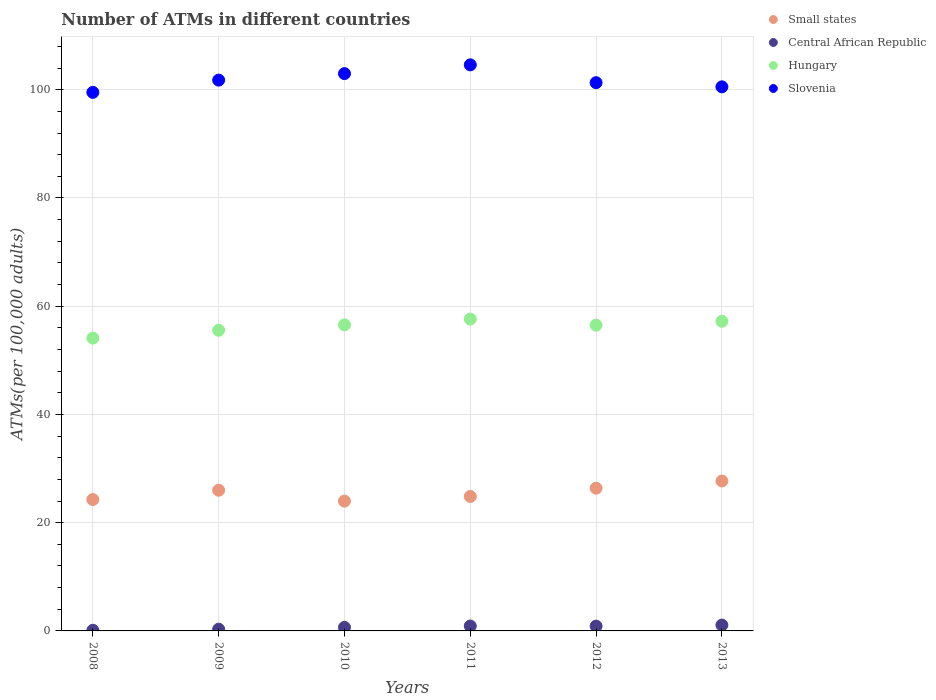What is the number of ATMs in Central African Republic in 2011?
Your answer should be very brief. 0.91. Across all years, what is the maximum number of ATMs in Hungary?
Make the answer very short. 57.63. Across all years, what is the minimum number of ATMs in Hungary?
Make the answer very short. 54.1. In which year was the number of ATMs in Small states minimum?
Your answer should be compact. 2010. What is the total number of ATMs in Slovenia in the graph?
Your response must be concise. 610.71. What is the difference between the number of ATMs in Hungary in 2009 and that in 2011?
Make the answer very short. -2.07. What is the difference between the number of ATMs in Small states in 2008 and the number of ATMs in Central African Republic in 2009?
Your answer should be very brief. 23.96. What is the average number of ATMs in Hungary per year?
Offer a terse response. 56.26. In the year 2010, what is the difference between the number of ATMs in Central African Republic and number of ATMs in Small states?
Your answer should be compact. -23.33. In how many years, is the number of ATMs in Small states greater than 76?
Provide a short and direct response. 0. What is the ratio of the number of ATMs in Slovenia in 2008 to that in 2011?
Your answer should be very brief. 0.95. Is the difference between the number of ATMs in Central African Republic in 2009 and 2010 greater than the difference between the number of ATMs in Small states in 2009 and 2010?
Give a very brief answer. No. What is the difference between the highest and the second highest number of ATMs in Small states?
Provide a short and direct response. 1.33. What is the difference between the highest and the lowest number of ATMs in Central African Republic?
Your response must be concise. 0.96. In how many years, is the number of ATMs in Slovenia greater than the average number of ATMs in Slovenia taken over all years?
Offer a terse response. 2. Does the number of ATMs in Hungary monotonically increase over the years?
Your answer should be very brief. No. Is the number of ATMs in Hungary strictly greater than the number of ATMs in Small states over the years?
Give a very brief answer. Yes. Is the number of ATMs in Central African Republic strictly less than the number of ATMs in Small states over the years?
Your answer should be very brief. Yes. How many years are there in the graph?
Give a very brief answer. 6. What is the difference between two consecutive major ticks on the Y-axis?
Provide a succinct answer. 20. How many legend labels are there?
Your answer should be compact. 4. What is the title of the graph?
Your response must be concise. Number of ATMs in different countries. Does "Estonia" appear as one of the legend labels in the graph?
Provide a succinct answer. No. What is the label or title of the X-axis?
Offer a very short reply. Years. What is the label or title of the Y-axis?
Give a very brief answer. ATMs(per 100,0 adults). What is the ATMs(per 100,000 adults) of Small states in 2008?
Your answer should be compact. 24.28. What is the ATMs(per 100,000 adults) in Central African Republic in 2008?
Ensure brevity in your answer.  0.12. What is the ATMs(per 100,000 adults) of Hungary in 2008?
Offer a very short reply. 54.1. What is the ATMs(per 100,000 adults) in Slovenia in 2008?
Make the answer very short. 99.51. What is the ATMs(per 100,000 adults) of Small states in 2009?
Provide a succinct answer. 26. What is the ATMs(per 100,000 adults) of Central African Republic in 2009?
Keep it short and to the point. 0.32. What is the ATMs(per 100,000 adults) in Hungary in 2009?
Ensure brevity in your answer.  55.56. What is the ATMs(per 100,000 adults) of Slovenia in 2009?
Your response must be concise. 101.78. What is the ATMs(per 100,000 adults) in Small states in 2010?
Keep it short and to the point. 23.99. What is the ATMs(per 100,000 adults) of Central African Republic in 2010?
Ensure brevity in your answer.  0.66. What is the ATMs(per 100,000 adults) of Hungary in 2010?
Provide a succinct answer. 56.55. What is the ATMs(per 100,000 adults) in Slovenia in 2010?
Your response must be concise. 102.98. What is the ATMs(per 100,000 adults) in Small states in 2011?
Give a very brief answer. 24.84. What is the ATMs(per 100,000 adults) of Central African Republic in 2011?
Keep it short and to the point. 0.91. What is the ATMs(per 100,000 adults) in Hungary in 2011?
Your answer should be very brief. 57.63. What is the ATMs(per 100,000 adults) in Slovenia in 2011?
Give a very brief answer. 104.6. What is the ATMs(per 100,000 adults) of Small states in 2012?
Your answer should be compact. 26.37. What is the ATMs(per 100,000 adults) in Central African Republic in 2012?
Your response must be concise. 0.88. What is the ATMs(per 100,000 adults) of Hungary in 2012?
Provide a short and direct response. 56.49. What is the ATMs(per 100,000 adults) of Slovenia in 2012?
Offer a very short reply. 101.3. What is the ATMs(per 100,000 adults) in Small states in 2013?
Your answer should be very brief. 27.7. What is the ATMs(per 100,000 adults) in Central African Republic in 2013?
Make the answer very short. 1.08. What is the ATMs(per 100,000 adults) of Hungary in 2013?
Keep it short and to the point. 57.22. What is the ATMs(per 100,000 adults) of Slovenia in 2013?
Provide a succinct answer. 100.53. Across all years, what is the maximum ATMs(per 100,000 adults) in Small states?
Provide a short and direct response. 27.7. Across all years, what is the maximum ATMs(per 100,000 adults) of Central African Republic?
Give a very brief answer. 1.08. Across all years, what is the maximum ATMs(per 100,000 adults) of Hungary?
Your response must be concise. 57.63. Across all years, what is the maximum ATMs(per 100,000 adults) of Slovenia?
Your response must be concise. 104.6. Across all years, what is the minimum ATMs(per 100,000 adults) in Small states?
Make the answer very short. 23.99. Across all years, what is the minimum ATMs(per 100,000 adults) of Central African Republic?
Make the answer very short. 0.12. Across all years, what is the minimum ATMs(per 100,000 adults) of Hungary?
Provide a succinct answer. 54.1. Across all years, what is the minimum ATMs(per 100,000 adults) in Slovenia?
Keep it short and to the point. 99.51. What is the total ATMs(per 100,000 adults) in Small states in the graph?
Provide a succinct answer. 153.18. What is the total ATMs(per 100,000 adults) of Central African Republic in the graph?
Provide a succinct answer. 3.97. What is the total ATMs(per 100,000 adults) of Hungary in the graph?
Your answer should be very brief. 337.55. What is the total ATMs(per 100,000 adults) of Slovenia in the graph?
Make the answer very short. 610.71. What is the difference between the ATMs(per 100,000 adults) of Small states in 2008 and that in 2009?
Your answer should be compact. -1.72. What is the difference between the ATMs(per 100,000 adults) of Central African Republic in 2008 and that in 2009?
Offer a very short reply. -0.2. What is the difference between the ATMs(per 100,000 adults) of Hungary in 2008 and that in 2009?
Ensure brevity in your answer.  -1.46. What is the difference between the ATMs(per 100,000 adults) of Slovenia in 2008 and that in 2009?
Your answer should be compact. -2.27. What is the difference between the ATMs(per 100,000 adults) of Small states in 2008 and that in 2010?
Keep it short and to the point. 0.29. What is the difference between the ATMs(per 100,000 adults) in Central African Republic in 2008 and that in 2010?
Give a very brief answer. -0.54. What is the difference between the ATMs(per 100,000 adults) of Hungary in 2008 and that in 2010?
Give a very brief answer. -2.45. What is the difference between the ATMs(per 100,000 adults) in Slovenia in 2008 and that in 2010?
Keep it short and to the point. -3.47. What is the difference between the ATMs(per 100,000 adults) of Small states in 2008 and that in 2011?
Keep it short and to the point. -0.57. What is the difference between the ATMs(per 100,000 adults) of Central African Republic in 2008 and that in 2011?
Provide a succinct answer. -0.79. What is the difference between the ATMs(per 100,000 adults) in Hungary in 2008 and that in 2011?
Provide a succinct answer. -3.52. What is the difference between the ATMs(per 100,000 adults) in Slovenia in 2008 and that in 2011?
Your answer should be very brief. -5.09. What is the difference between the ATMs(per 100,000 adults) of Small states in 2008 and that in 2012?
Your response must be concise. -2.09. What is the difference between the ATMs(per 100,000 adults) of Central African Republic in 2008 and that in 2012?
Provide a short and direct response. -0.76. What is the difference between the ATMs(per 100,000 adults) in Hungary in 2008 and that in 2012?
Give a very brief answer. -2.39. What is the difference between the ATMs(per 100,000 adults) in Slovenia in 2008 and that in 2012?
Offer a terse response. -1.79. What is the difference between the ATMs(per 100,000 adults) of Small states in 2008 and that in 2013?
Give a very brief answer. -3.43. What is the difference between the ATMs(per 100,000 adults) of Central African Republic in 2008 and that in 2013?
Provide a succinct answer. -0.96. What is the difference between the ATMs(per 100,000 adults) in Hungary in 2008 and that in 2013?
Ensure brevity in your answer.  -3.11. What is the difference between the ATMs(per 100,000 adults) in Slovenia in 2008 and that in 2013?
Offer a terse response. -1.02. What is the difference between the ATMs(per 100,000 adults) of Small states in 2009 and that in 2010?
Your answer should be very brief. 2.01. What is the difference between the ATMs(per 100,000 adults) of Central African Republic in 2009 and that in 2010?
Keep it short and to the point. -0.34. What is the difference between the ATMs(per 100,000 adults) in Hungary in 2009 and that in 2010?
Give a very brief answer. -0.99. What is the difference between the ATMs(per 100,000 adults) of Slovenia in 2009 and that in 2010?
Offer a terse response. -1.2. What is the difference between the ATMs(per 100,000 adults) in Small states in 2009 and that in 2011?
Provide a short and direct response. 1.15. What is the difference between the ATMs(per 100,000 adults) in Central African Republic in 2009 and that in 2011?
Offer a very short reply. -0.59. What is the difference between the ATMs(per 100,000 adults) in Hungary in 2009 and that in 2011?
Your answer should be very brief. -2.07. What is the difference between the ATMs(per 100,000 adults) in Slovenia in 2009 and that in 2011?
Offer a very short reply. -2.82. What is the difference between the ATMs(per 100,000 adults) of Small states in 2009 and that in 2012?
Provide a succinct answer. -0.38. What is the difference between the ATMs(per 100,000 adults) in Central African Republic in 2009 and that in 2012?
Provide a short and direct response. -0.57. What is the difference between the ATMs(per 100,000 adults) of Hungary in 2009 and that in 2012?
Provide a short and direct response. -0.93. What is the difference between the ATMs(per 100,000 adults) in Slovenia in 2009 and that in 2012?
Make the answer very short. 0.47. What is the difference between the ATMs(per 100,000 adults) of Small states in 2009 and that in 2013?
Keep it short and to the point. -1.71. What is the difference between the ATMs(per 100,000 adults) in Central African Republic in 2009 and that in 2013?
Make the answer very short. -0.76. What is the difference between the ATMs(per 100,000 adults) in Hungary in 2009 and that in 2013?
Your answer should be compact. -1.66. What is the difference between the ATMs(per 100,000 adults) in Slovenia in 2009 and that in 2013?
Your answer should be compact. 1.25. What is the difference between the ATMs(per 100,000 adults) in Small states in 2010 and that in 2011?
Offer a terse response. -0.86. What is the difference between the ATMs(per 100,000 adults) of Central African Republic in 2010 and that in 2011?
Keep it short and to the point. -0.25. What is the difference between the ATMs(per 100,000 adults) of Hungary in 2010 and that in 2011?
Your response must be concise. -1.08. What is the difference between the ATMs(per 100,000 adults) of Slovenia in 2010 and that in 2011?
Your response must be concise. -1.62. What is the difference between the ATMs(per 100,000 adults) of Small states in 2010 and that in 2012?
Ensure brevity in your answer.  -2.39. What is the difference between the ATMs(per 100,000 adults) of Central African Republic in 2010 and that in 2012?
Give a very brief answer. -0.23. What is the difference between the ATMs(per 100,000 adults) of Hungary in 2010 and that in 2012?
Give a very brief answer. 0.06. What is the difference between the ATMs(per 100,000 adults) in Slovenia in 2010 and that in 2012?
Your answer should be very brief. 1.68. What is the difference between the ATMs(per 100,000 adults) of Small states in 2010 and that in 2013?
Your response must be concise. -3.72. What is the difference between the ATMs(per 100,000 adults) of Central African Republic in 2010 and that in 2013?
Offer a very short reply. -0.42. What is the difference between the ATMs(per 100,000 adults) of Hungary in 2010 and that in 2013?
Your answer should be very brief. -0.67. What is the difference between the ATMs(per 100,000 adults) of Slovenia in 2010 and that in 2013?
Your answer should be compact. 2.45. What is the difference between the ATMs(per 100,000 adults) in Small states in 2011 and that in 2012?
Keep it short and to the point. -1.53. What is the difference between the ATMs(per 100,000 adults) of Central African Republic in 2011 and that in 2012?
Your answer should be compact. 0.02. What is the difference between the ATMs(per 100,000 adults) in Hungary in 2011 and that in 2012?
Provide a short and direct response. 1.13. What is the difference between the ATMs(per 100,000 adults) in Slovenia in 2011 and that in 2012?
Your answer should be very brief. 3.29. What is the difference between the ATMs(per 100,000 adults) in Small states in 2011 and that in 2013?
Give a very brief answer. -2.86. What is the difference between the ATMs(per 100,000 adults) of Central African Republic in 2011 and that in 2013?
Give a very brief answer. -0.17. What is the difference between the ATMs(per 100,000 adults) in Hungary in 2011 and that in 2013?
Offer a terse response. 0.41. What is the difference between the ATMs(per 100,000 adults) of Slovenia in 2011 and that in 2013?
Keep it short and to the point. 4.07. What is the difference between the ATMs(per 100,000 adults) of Small states in 2012 and that in 2013?
Your answer should be very brief. -1.33. What is the difference between the ATMs(per 100,000 adults) in Central African Republic in 2012 and that in 2013?
Keep it short and to the point. -0.2. What is the difference between the ATMs(per 100,000 adults) of Hungary in 2012 and that in 2013?
Offer a very short reply. -0.72. What is the difference between the ATMs(per 100,000 adults) in Slovenia in 2012 and that in 2013?
Keep it short and to the point. 0.77. What is the difference between the ATMs(per 100,000 adults) in Small states in 2008 and the ATMs(per 100,000 adults) in Central African Republic in 2009?
Your response must be concise. 23.96. What is the difference between the ATMs(per 100,000 adults) of Small states in 2008 and the ATMs(per 100,000 adults) of Hungary in 2009?
Keep it short and to the point. -31.28. What is the difference between the ATMs(per 100,000 adults) of Small states in 2008 and the ATMs(per 100,000 adults) of Slovenia in 2009?
Offer a terse response. -77.5. What is the difference between the ATMs(per 100,000 adults) in Central African Republic in 2008 and the ATMs(per 100,000 adults) in Hungary in 2009?
Your response must be concise. -55.44. What is the difference between the ATMs(per 100,000 adults) in Central African Republic in 2008 and the ATMs(per 100,000 adults) in Slovenia in 2009?
Your answer should be compact. -101.66. What is the difference between the ATMs(per 100,000 adults) of Hungary in 2008 and the ATMs(per 100,000 adults) of Slovenia in 2009?
Make the answer very short. -47.67. What is the difference between the ATMs(per 100,000 adults) of Small states in 2008 and the ATMs(per 100,000 adults) of Central African Republic in 2010?
Make the answer very short. 23.62. What is the difference between the ATMs(per 100,000 adults) in Small states in 2008 and the ATMs(per 100,000 adults) in Hungary in 2010?
Give a very brief answer. -32.27. What is the difference between the ATMs(per 100,000 adults) of Small states in 2008 and the ATMs(per 100,000 adults) of Slovenia in 2010?
Provide a short and direct response. -78.7. What is the difference between the ATMs(per 100,000 adults) of Central African Republic in 2008 and the ATMs(per 100,000 adults) of Hungary in 2010?
Offer a terse response. -56.43. What is the difference between the ATMs(per 100,000 adults) in Central African Republic in 2008 and the ATMs(per 100,000 adults) in Slovenia in 2010?
Give a very brief answer. -102.86. What is the difference between the ATMs(per 100,000 adults) of Hungary in 2008 and the ATMs(per 100,000 adults) of Slovenia in 2010?
Offer a very short reply. -48.88. What is the difference between the ATMs(per 100,000 adults) in Small states in 2008 and the ATMs(per 100,000 adults) in Central African Republic in 2011?
Provide a succinct answer. 23.37. What is the difference between the ATMs(per 100,000 adults) of Small states in 2008 and the ATMs(per 100,000 adults) of Hungary in 2011?
Provide a short and direct response. -33.35. What is the difference between the ATMs(per 100,000 adults) in Small states in 2008 and the ATMs(per 100,000 adults) in Slovenia in 2011?
Offer a very short reply. -80.32. What is the difference between the ATMs(per 100,000 adults) of Central African Republic in 2008 and the ATMs(per 100,000 adults) of Hungary in 2011?
Make the answer very short. -57.51. What is the difference between the ATMs(per 100,000 adults) in Central African Republic in 2008 and the ATMs(per 100,000 adults) in Slovenia in 2011?
Give a very brief answer. -104.48. What is the difference between the ATMs(per 100,000 adults) of Hungary in 2008 and the ATMs(per 100,000 adults) of Slovenia in 2011?
Give a very brief answer. -50.5. What is the difference between the ATMs(per 100,000 adults) in Small states in 2008 and the ATMs(per 100,000 adults) in Central African Republic in 2012?
Keep it short and to the point. 23.39. What is the difference between the ATMs(per 100,000 adults) in Small states in 2008 and the ATMs(per 100,000 adults) in Hungary in 2012?
Offer a terse response. -32.22. What is the difference between the ATMs(per 100,000 adults) of Small states in 2008 and the ATMs(per 100,000 adults) of Slovenia in 2012?
Give a very brief answer. -77.03. What is the difference between the ATMs(per 100,000 adults) of Central African Republic in 2008 and the ATMs(per 100,000 adults) of Hungary in 2012?
Offer a very short reply. -56.37. What is the difference between the ATMs(per 100,000 adults) in Central African Republic in 2008 and the ATMs(per 100,000 adults) in Slovenia in 2012?
Give a very brief answer. -101.18. What is the difference between the ATMs(per 100,000 adults) in Hungary in 2008 and the ATMs(per 100,000 adults) in Slovenia in 2012?
Offer a very short reply. -47.2. What is the difference between the ATMs(per 100,000 adults) in Small states in 2008 and the ATMs(per 100,000 adults) in Central African Republic in 2013?
Provide a short and direct response. 23.2. What is the difference between the ATMs(per 100,000 adults) in Small states in 2008 and the ATMs(per 100,000 adults) in Hungary in 2013?
Keep it short and to the point. -32.94. What is the difference between the ATMs(per 100,000 adults) in Small states in 2008 and the ATMs(per 100,000 adults) in Slovenia in 2013?
Provide a short and direct response. -76.26. What is the difference between the ATMs(per 100,000 adults) in Central African Republic in 2008 and the ATMs(per 100,000 adults) in Hungary in 2013?
Your answer should be very brief. -57.09. What is the difference between the ATMs(per 100,000 adults) in Central African Republic in 2008 and the ATMs(per 100,000 adults) in Slovenia in 2013?
Make the answer very short. -100.41. What is the difference between the ATMs(per 100,000 adults) in Hungary in 2008 and the ATMs(per 100,000 adults) in Slovenia in 2013?
Provide a short and direct response. -46.43. What is the difference between the ATMs(per 100,000 adults) of Small states in 2009 and the ATMs(per 100,000 adults) of Central African Republic in 2010?
Your answer should be compact. 25.34. What is the difference between the ATMs(per 100,000 adults) of Small states in 2009 and the ATMs(per 100,000 adults) of Hungary in 2010?
Your answer should be compact. -30.56. What is the difference between the ATMs(per 100,000 adults) in Small states in 2009 and the ATMs(per 100,000 adults) in Slovenia in 2010?
Your answer should be compact. -76.98. What is the difference between the ATMs(per 100,000 adults) in Central African Republic in 2009 and the ATMs(per 100,000 adults) in Hungary in 2010?
Provide a short and direct response. -56.23. What is the difference between the ATMs(per 100,000 adults) of Central African Republic in 2009 and the ATMs(per 100,000 adults) of Slovenia in 2010?
Your answer should be compact. -102.66. What is the difference between the ATMs(per 100,000 adults) in Hungary in 2009 and the ATMs(per 100,000 adults) in Slovenia in 2010?
Your response must be concise. -47.42. What is the difference between the ATMs(per 100,000 adults) of Small states in 2009 and the ATMs(per 100,000 adults) of Central African Republic in 2011?
Offer a terse response. 25.09. What is the difference between the ATMs(per 100,000 adults) of Small states in 2009 and the ATMs(per 100,000 adults) of Hungary in 2011?
Your response must be concise. -31.63. What is the difference between the ATMs(per 100,000 adults) in Small states in 2009 and the ATMs(per 100,000 adults) in Slovenia in 2011?
Give a very brief answer. -78.6. What is the difference between the ATMs(per 100,000 adults) of Central African Republic in 2009 and the ATMs(per 100,000 adults) of Hungary in 2011?
Provide a succinct answer. -57.31. What is the difference between the ATMs(per 100,000 adults) in Central African Republic in 2009 and the ATMs(per 100,000 adults) in Slovenia in 2011?
Your answer should be compact. -104.28. What is the difference between the ATMs(per 100,000 adults) in Hungary in 2009 and the ATMs(per 100,000 adults) in Slovenia in 2011?
Offer a terse response. -49.04. What is the difference between the ATMs(per 100,000 adults) in Small states in 2009 and the ATMs(per 100,000 adults) in Central African Republic in 2012?
Your answer should be very brief. 25.11. What is the difference between the ATMs(per 100,000 adults) in Small states in 2009 and the ATMs(per 100,000 adults) in Hungary in 2012?
Provide a succinct answer. -30.5. What is the difference between the ATMs(per 100,000 adults) in Small states in 2009 and the ATMs(per 100,000 adults) in Slovenia in 2012?
Provide a succinct answer. -75.31. What is the difference between the ATMs(per 100,000 adults) of Central African Republic in 2009 and the ATMs(per 100,000 adults) of Hungary in 2012?
Your answer should be compact. -56.18. What is the difference between the ATMs(per 100,000 adults) in Central African Republic in 2009 and the ATMs(per 100,000 adults) in Slovenia in 2012?
Ensure brevity in your answer.  -100.99. What is the difference between the ATMs(per 100,000 adults) of Hungary in 2009 and the ATMs(per 100,000 adults) of Slovenia in 2012?
Give a very brief answer. -45.74. What is the difference between the ATMs(per 100,000 adults) in Small states in 2009 and the ATMs(per 100,000 adults) in Central African Republic in 2013?
Keep it short and to the point. 24.92. What is the difference between the ATMs(per 100,000 adults) of Small states in 2009 and the ATMs(per 100,000 adults) of Hungary in 2013?
Your response must be concise. -31.22. What is the difference between the ATMs(per 100,000 adults) of Small states in 2009 and the ATMs(per 100,000 adults) of Slovenia in 2013?
Keep it short and to the point. -74.54. What is the difference between the ATMs(per 100,000 adults) in Central African Republic in 2009 and the ATMs(per 100,000 adults) in Hungary in 2013?
Your answer should be very brief. -56.9. What is the difference between the ATMs(per 100,000 adults) in Central African Republic in 2009 and the ATMs(per 100,000 adults) in Slovenia in 2013?
Your response must be concise. -100.22. What is the difference between the ATMs(per 100,000 adults) of Hungary in 2009 and the ATMs(per 100,000 adults) of Slovenia in 2013?
Offer a very short reply. -44.97. What is the difference between the ATMs(per 100,000 adults) of Small states in 2010 and the ATMs(per 100,000 adults) of Central African Republic in 2011?
Your answer should be compact. 23.08. What is the difference between the ATMs(per 100,000 adults) in Small states in 2010 and the ATMs(per 100,000 adults) in Hungary in 2011?
Your response must be concise. -33.64. What is the difference between the ATMs(per 100,000 adults) in Small states in 2010 and the ATMs(per 100,000 adults) in Slovenia in 2011?
Your answer should be compact. -80.61. What is the difference between the ATMs(per 100,000 adults) of Central African Republic in 2010 and the ATMs(per 100,000 adults) of Hungary in 2011?
Your answer should be compact. -56.97. What is the difference between the ATMs(per 100,000 adults) in Central African Republic in 2010 and the ATMs(per 100,000 adults) in Slovenia in 2011?
Provide a short and direct response. -103.94. What is the difference between the ATMs(per 100,000 adults) in Hungary in 2010 and the ATMs(per 100,000 adults) in Slovenia in 2011?
Your answer should be very brief. -48.05. What is the difference between the ATMs(per 100,000 adults) of Small states in 2010 and the ATMs(per 100,000 adults) of Central African Republic in 2012?
Provide a succinct answer. 23.1. What is the difference between the ATMs(per 100,000 adults) in Small states in 2010 and the ATMs(per 100,000 adults) in Hungary in 2012?
Your response must be concise. -32.51. What is the difference between the ATMs(per 100,000 adults) of Small states in 2010 and the ATMs(per 100,000 adults) of Slovenia in 2012?
Make the answer very short. -77.32. What is the difference between the ATMs(per 100,000 adults) in Central African Republic in 2010 and the ATMs(per 100,000 adults) in Hungary in 2012?
Provide a short and direct response. -55.84. What is the difference between the ATMs(per 100,000 adults) of Central African Republic in 2010 and the ATMs(per 100,000 adults) of Slovenia in 2012?
Provide a short and direct response. -100.65. What is the difference between the ATMs(per 100,000 adults) of Hungary in 2010 and the ATMs(per 100,000 adults) of Slovenia in 2012?
Your answer should be compact. -44.75. What is the difference between the ATMs(per 100,000 adults) in Small states in 2010 and the ATMs(per 100,000 adults) in Central African Republic in 2013?
Provide a short and direct response. 22.91. What is the difference between the ATMs(per 100,000 adults) of Small states in 2010 and the ATMs(per 100,000 adults) of Hungary in 2013?
Your answer should be compact. -33.23. What is the difference between the ATMs(per 100,000 adults) of Small states in 2010 and the ATMs(per 100,000 adults) of Slovenia in 2013?
Your answer should be compact. -76.55. What is the difference between the ATMs(per 100,000 adults) in Central African Republic in 2010 and the ATMs(per 100,000 adults) in Hungary in 2013?
Your answer should be very brief. -56.56. What is the difference between the ATMs(per 100,000 adults) in Central African Republic in 2010 and the ATMs(per 100,000 adults) in Slovenia in 2013?
Keep it short and to the point. -99.87. What is the difference between the ATMs(per 100,000 adults) in Hungary in 2010 and the ATMs(per 100,000 adults) in Slovenia in 2013?
Your answer should be very brief. -43.98. What is the difference between the ATMs(per 100,000 adults) in Small states in 2011 and the ATMs(per 100,000 adults) in Central African Republic in 2012?
Ensure brevity in your answer.  23.96. What is the difference between the ATMs(per 100,000 adults) of Small states in 2011 and the ATMs(per 100,000 adults) of Hungary in 2012?
Your response must be concise. -31.65. What is the difference between the ATMs(per 100,000 adults) of Small states in 2011 and the ATMs(per 100,000 adults) of Slovenia in 2012?
Keep it short and to the point. -76.46. What is the difference between the ATMs(per 100,000 adults) of Central African Republic in 2011 and the ATMs(per 100,000 adults) of Hungary in 2012?
Your answer should be compact. -55.59. What is the difference between the ATMs(per 100,000 adults) of Central African Republic in 2011 and the ATMs(per 100,000 adults) of Slovenia in 2012?
Your answer should be compact. -100.4. What is the difference between the ATMs(per 100,000 adults) of Hungary in 2011 and the ATMs(per 100,000 adults) of Slovenia in 2012?
Your response must be concise. -43.68. What is the difference between the ATMs(per 100,000 adults) of Small states in 2011 and the ATMs(per 100,000 adults) of Central African Republic in 2013?
Offer a very short reply. 23.76. What is the difference between the ATMs(per 100,000 adults) in Small states in 2011 and the ATMs(per 100,000 adults) in Hungary in 2013?
Provide a short and direct response. -32.37. What is the difference between the ATMs(per 100,000 adults) of Small states in 2011 and the ATMs(per 100,000 adults) of Slovenia in 2013?
Your answer should be very brief. -75.69. What is the difference between the ATMs(per 100,000 adults) in Central African Republic in 2011 and the ATMs(per 100,000 adults) in Hungary in 2013?
Give a very brief answer. -56.31. What is the difference between the ATMs(per 100,000 adults) in Central African Republic in 2011 and the ATMs(per 100,000 adults) in Slovenia in 2013?
Your answer should be compact. -99.63. What is the difference between the ATMs(per 100,000 adults) of Hungary in 2011 and the ATMs(per 100,000 adults) of Slovenia in 2013?
Provide a short and direct response. -42.91. What is the difference between the ATMs(per 100,000 adults) of Small states in 2012 and the ATMs(per 100,000 adults) of Central African Republic in 2013?
Provide a short and direct response. 25.29. What is the difference between the ATMs(per 100,000 adults) of Small states in 2012 and the ATMs(per 100,000 adults) of Hungary in 2013?
Provide a succinct answer. -30.84. What is the difference between the ATMs(per 100,000 adults) in Small states in 2012 and the ATMs(per 100,000 adults) in Slovenia in 2013?
Offer a very short reply. -74.16. What is the difference between the ATMs(per 100,000 adults) of Central African Republic in 2012 and the ATMs(per 100,000 adults) of Hungary in 2013?
Your response must be concise. -56.33. What is the difference between the ATMs(per 100,000 adults) of Central African Republic in 2012 and the ATMs(per 100,000 adults) of Slovenia in 2013?
Keep it short and to the point. -99.65. What is the difference between the ATMs(per 100,000 adults) of Hungary in 2012 and the ATMs(per 100,000 adults) of Slovenia in 2013?
Offer a terse response. -44.04. What is the average ATMs(per 100,000 adults) of Small states per year?
Your response must be concise. 25.53. What is the average ATMs(per 100,000 adults) of Central African Republic per year?
Make the answer very short. 0.66. What is the average ATMs(per 100,000 adults) of Hungary per year?
Your answer should be very brief. 56.26. What is the average ATMs(per 100,000 adults) of Slovenia per year?
Your answer should be very brief. 101.78. In the year 2008, what is the difference between the ATMs(per 100,000 adults) of Small states and ATMs(per 100,000 adults) of Central African Republic?
Offer a terse response. 24.16. In the year 2008, what is the difference between the ATMs(per 100,000 adults) in Small states and ATMs(per 100,000 adults) in Hungary?
Your answer should be very brief. -29.83. In the year 2008, what is the difference between the ATMs(per 100,000 adults) in Small states and ATMs(per 100,000 adults) in Slovenia?
Offer a very short reply. -75.24. In the year 2008, what is the difference between the ATMs(per 100,000 adults) of Central African Republic and ATMs(per 100,000 adults) of Hungary?
Make the answer very short. -53.98. In the year 2008, what is the difference between the ATMs(per 100,000 adults) in Central African Republic and ATMs(per 100,000 adults) in Slovenia?
Your answer should be very brief. -99.39. In the year 2008, what is the difference between the ATMs(per 100,000 adults) of Hungary and ATMs(per 100,000 adults) of Slovenia?
Your response must be concise. -45.41. In the year 2009, what is the difference between the ATMs(per 100,000 adults) of Small states and ATMs(per 100,000 adults) of Central African Republic?
Provide a succinct answer. 25.68. In the year 2009, what is the difference between the ATMs(per 100,000 adults) of Small states and ATMs(per 100,000 adults) of Hungary?
Keep it short and to the point. -29.56. In the year 2009, what is the difference between the ATMs(per 100,000 adults) in Small states and ATMs(per 100,000 adults) in Slovenia?
Give a very brief answer. -75.78. In the year 2009, what is the difference between the ATMs(per 100,000 adults) of Central African Republic and ATMs(per 100,000 adults) of Hungary?
Provide a short and direct response. -55.24. In the year 2009, what is the difference between the ATMs(per 100,000 adults) in Central African Republic and ATMs(per 100,000 adults) in Slovenia?
Provide a succinct answer. -101.46. In the year 2009, what is the difference between the ATMs(per 100,000 adults) of Hungary and ATMs(per 100,000 adults) of Slovenia?
Provide a succinct answer. -46.22. In the year 2010, what is the difference between the ATMs(per 100,000 adults) in Small states and ATMs(per 100,000 adults) in Central African Republic?
Ensure brevity in your answer.  23.33. In the year 2010, what is the difference between the ATMs(per 100,000 adults) of Small states and ATMs(per 100,000 adults) of Hungary?
Provide a short and direct response. -32.57. In the year 2010, what is the difference between the ATMs(per 100,000 adults) in Small states and ATMs(per 100,000 adults) in Slovenia?
Your answer should be compact. -78.99. In the year 2010, what is the difference between the ATMs(per 100,000 adults) in Central African Republic and ATMs(per 100,000 adults) in Hungary?
Your answer should be very brief. -55.89. In the year 2010, what is the difference between the ATMs(per 100,000 adults) in Central African Republic and ATMs(per 100,000 adults) in Slovenia?
Provide a short and direct response. -102.32. In the year 2010, what is the difference between the ATMs(per 100,000 adults) in Hungary and ATMs(per 100,000 adults) in Slovenia?
Give a very brief answer. -46.43. In the year 2011, what is the difference between the ATMs(per 100,000 adults) of Small states and ATMs(per 100,000 adults) of Central African Republic?
Make the answer very short. 23.94. In the year 2011, what is the difference between the ATMs(per 100,000 adults) of Small states and ATMs(per 100,000 adults) of Hungary?
Your answer should be compact. -32.78. In the year 2011, what is the difference between the ATMs(per 100,000 adults) of Small states and ATMs(per 100,000 adults) of Slovenia?
Give a very brief answer. -79.75. In the year 2011, what is the difference between the ATMs(per 100,000 adults) of Central African Republic and ATMs(per 100,000 adults) of Hungary?
Provide a short and direct response. -56.72. In the year 2011, what is the difference between the ATMs(per 100,000 adults) in Central African Republic and ATMs(per 100,000 adults) in Slovenia?
Provide a succinct answer. -103.69. In the year 2011, what is the difference between the ATMs(per 100,000 adults) of Hungary and ATMs(per 100,000 adults) of Slovenia?
Your answer should be compact. -46.97. In the year 2012, what is the difference between the ATMs(per 100,000 adults) in Small states and ATMs(per 100,000 adults) in Central African Republic?
Your response must be concise. 25.49. In the year 2012, what is the difference between the ATMs(per 100,000 adults) in Small states and ATMs(per 100,000 adults) in Hungary?
Offer a very short reply. -30.12. In the year 2012, what is the difference between the ATMs(per 100,000 adults) in Small states and ATMs(per 100,000 adults) in Slovenia?
Your answer should be very brief. -74.93. In the year 2012, what is the difference between the ATMs(per 100,000 adults) in Central African Republic and ATMs(per 100,000 adults) in Hungary?
Your answer should be very brief. -55.61. In the year 2012, what is the difference between the ATMs(per 100,000 adults) of Central African Republic and ATMs(per 100,000 adults) of Slovenia?
Make the answer very short. -100.42. In the year 2012, what is the difference between the ATMs(per 100,000 adults) in Hungary and ATMs(per 100,000 adults) in Slovenia?
Provide a succinct answer. -44.81. In the year 2013, what is the difference between the ATMs(per 100,000 adults) of Small states and ATMs(per 100,000 adults) of Central African Republic?
Give a very brief answer. 26.62. In the year 2013, what is the difference between the ATMs(per 100,000 adults) in Small states and ATMs(per 100,000 adults) in Hungary?
Your response must be concise. -29.51. In the year 2013, what is the difference between the ATMs(per 100,000 adults) in Small states and ATMs(per 100,000 adults) in Slovenia?
Your answer should be compact. -72.83. In the year 2013, what is the difference between the ATMs(per 100,000 adults) in Central African Republic and ATMs(per 100,000 adults) in Hungary?
Provide a succinct answer. -56.14. In the year 2013, what is the difference between the ATMs(per 100,000 adults) of Central African Republic and ATMs(per 100,000 adults) of Slovenia?
Ensure brevity in your answer.  -99.45. In the year 2013, what is the difference between the ATMs(per 100,000 adults) in Hungary and ATMs(per 100,000 adults) in Slovenia?
Ensure brevity in your answer.  -43.32. What is the ratio of the ATMs(per 100,000 adults) of Small states in 2008 to that in 2009?
Offer a very short reply. 0.93. What is the ratio of the ATMs(per 100,000 adults) in Central African Republic in 2008 to that in 2009?
Make the answer very short. 0.38. What is the ratio of the ATMs(per 100,000 adults) of Hungary in 2008 to that in 2009?
Your answer should be very brief. 0.97. What is the ratio of the ATMs(per 100,000 adults) of Slovenia in 2008 to that in 2009?
Provide a short and direct response. 0.98. What is the ratio of the ATMs(per 100,000 adults) in Small states in 2008 to that in 2010?
Give a very brief answer. 1.01. What is the ratio of the ATMs(per 100,000 adults) in Central African Republic in 2008 to that in 2010?
Provide a succinct answer. 0.19. What is the ratio of the ATMs(per 100,000 adults) in Hungary in 2008 to that in 2010?
Your answer should be very brief. 0.96. What is the ratio of the ATMs(per 100,000 adults) of Slovenia in 2008 to that in 2010?
Make the answer very short. 0.97. What is the ratio of the ATMs(per 100,000 adults) in Small states in 2008 to that in 2011?
Your response must be concise. 0.98. What is the ratio of the ATMs(per 100,000 adults) of Central African Republic in 2008 to that in 2011?
Provide a succinct answer. 0.13. What is the ratio of the ATMs(per 100,000 adults) of Hungary in 2008 to that in 2011?
Ensure brevity in your answer.  0.94. What is the ratio of the ATMs(per 100,000 adults) of Slovenia in 2008 to that in 2011?
Offer a terse response. 0.95. What is the ratio of the ATMs(per 100,000 adults) in Small states in 2008 to that in 2012?
Provide a succinct answer. 0.92. What is the ratio of the ATMs(per 100,000 adults) of Central African Republic in 2008 to that in 2012?
Provide a succinct answer. 0.14. What is the ratio of the ATMs(per 100,000 adults) of Hungary in 2008 to that in 2012?
Your response must be concise. 0.96. What is the ratio of the ATMs(per 100,000 adults) of Slovenia in 2008 to that in 2012?
Ensure brevity in your answer.  0.98. What is the ratio of the ATMs(per 100,000 adults) of Small states in 2008 to that in 2013?
Offer a very short reply. 0.88. What is the ratio of the ATMs(per 100,000 adults) of Central African Republic in 2008 to that in 2013?
Keep it short and to the point. 0.11. What is the ratio of the ATMs(per 100,000 adults) of Hungary in 2008 to that in 2013?
Keep it short and to the point. 0.95. What is the ratio of the ATMs(per 100,000 adults) in Small states in 2009 to that in 2010?
Give a very brief answer. 1.08. What is the ratio of the ATMs(per 100,000 adults) of Central African Republic in 2009 to that in 2010?
Your answer should be compact. 0.48. What is the ratio of the ATMs(per 100,000 adults) of Hungary in 2009 to that in 2010?
Ensure brevity in your answer.  0.98. What is the ratio of the ATMs(per 100,000 adults) in Slovenia in 2009 to that in 2010?
Provide a short and direct response. 0.99. What is the ratio of the ATMs(per 100,000 adults) of Small states in 2009 to that in 2011?
Make the answer very short. 1.05. What is the ratio of the ATMs(per 100,000 adults) of Central African Republic in 2009 to that in 2011?
Keep it short and to the point. 0.35. What is the ratio of the ATMs(per 100,000 adults) of Hungary in 2009 to that in 2011?
Your answer should be compact. 0.96. What is the ratio of the ATMs(per 100,000 adults) in Small states in 2009 to that in 2012?
Your answer should be very brief. 0.99. What is the ratio of the ATMs(per 100,000 adults) in Central African Republic in 2009 to that in 2012?
Provide a succinct answer. 0.36. What is the ratio of the ATMs(per 100,000 adults) of Hungary in 2009 to that in 2012?
Offer a terse response. 0.98. What is the ratio of the ATMs(per 100,000 adults) of Slovenia in 2009 to that in 2012?
Keep it short and to the point. 1. What is the ratio of the ATMs(per 100,000 adults) of Small states in 2009 to that in 2013?
Keep it short and to the point. 0.94. What is the ratio of the ATMs(per 100,000 adults) in Central African Republic in 2009 to that in 2013?
Your answer should be compact. 0.29. What is the ratio of the ATMs(per 100,000 adults) in Hungary in 2009 to that in 2013?
Make the answer very short. 0.97. What is the ratio of the ATMs(per 100,000 adults) in Slovenia in 2009 to that in 2013?
Ensure brevity in your answer.  1.01. What is the ratio of the ATMs(per 100,000 adults) of Small states in 2010 to that in 2011?
Your answer should be very brief. 0.97. What is the ratio of the ATMs(per 100,000 adults) in Central African Republic in 2010 to that in 2011?
Offer a terse response. 0.73. What is the ratio of the ATMs(per 100,000 adults) in Hungary in 2010 to that in 2011?
Make the answer very short. 0.98. What is the ratio of the ATMs(per 100,000 adults) in Slovenia in 2010 to that in 2011?
Offer a very short reply. 0.98. What is the ratio of the ATMs(per 100,000 adults) in Small states in 2010 to that in 2012?
Provide a succinct answer. 0.91. What is the ratio of the ATMs(per 100,000 adults) in Central African Republic in 2010 to that in 2012?
Provide a succinct answer. 0.74. What is the ratio of the ATMs(per 100,000 adults) in Hungary in 2010 to that in 2012?
Give a very brief answer. 1. What is the ratio of the ATMs(per 100,000 adults) in Slovenia in 2010 to that in 2012?
Give a very brief answer. 1.02. What is the ratio of the ATMs(per 100,000 adults) of Small states in 2010 to that in 2013?
Offer a very short reply. 0.87. What is the ratio of the ATMs(per 100,000 adults) in Central African Republic in 2010 to that in 2013?
Make the answer very short. 0.61. What is the ratio of the ATMs(per 100,000 adults) of Hungary in 2010 to that in 2013?
Offer a terse response. 0.99. What is the ratio of the ATMs(per 100,000 adults) in Slovenia in 2010 to that in 2013?
Your answer should be very brief. 1.02. What is the ratio of the ATMs(per 100,000 adults) in Small states in 2011 to that in 2012?
Give a very brief answer. 0.94. What is the ratio of the ATMs(per 100,000 adults) of Central African Republic in 2011 to that in 2012?
Offer a very short reply. 1.03. What is the ratio of the ATMs(per 100,000 adults) in Hungary in 2011 to that in 2012?
Your response must be concise. 1.02. What is the ratio of the ATMs(per 100,000 adults) of Slovenia in 2011 to that in 2012?
Make the answer very short. 1.03. What is the ratio of the ATMs(per 100,000 adults) of Small states in 2011 to that in 2013?
Your response must be concise. 0.9. What is the ratio of the ATMs(per 100,000 adults) in Central African Republic in 2011 to that in 2013?
Provide a succinct answer. 0.84. What is the ratio of the ATMs(per 100,000 adults) in Slovenia in 2011 to that in 2013?
Provide a succinct answer. 1.04. What is the ratio of the ATMs(per 100,000 adults) of Small states in 2012 to that in 2013?
Provide a short and direct response. 0.95. What is the ratio of the ATMs(per 100,000 adults) in Central African Republic in 2012 to that in 2013?
Ensure brevity in your answer.  0.82. What is the ratio of the ATMs(per 100,000 adults) in Hungary in 2012 to that in 2013?
Offer a very short reply. 0.99. What is the ratio of the ATMs(per 100,000 adults) of Slovenia in 2012 to that in 2013?
Offer a very short reply. 1.01. What is the difference between the highest and the second highest ATMs(per 100,000 adults) of Small states?
Offer a very short reply. 1.33. What is the difference between the highest and the second highest ATMs(per 100,000 adults) in Central African Republic?
Offer a very short reply. 0.17. What is the difference between the highest and the second highest ATMs(per 100,000 adults) of Hungary?
Keep it short and to the point. 0.41. What is the difference between the highest and the second highest ATMs(per 100,000 adults) in Slovenia?
Provide a short and direct response. 1.62. What is the difference between the highest and the lowest ATMs(per 100,000 adults) in Small states?
Offer a very short reply. 3.72. What is the difference between the highest and the lowest ATMs(per 100,000 adults) in Central African Republic?
Provide a short and direct response. 0.96. What is the difference between the highest and the lowest ATMs(per 100,000 adults) in Hungary?
Ensure brevity in your answer.  3.52. What is the difference between the highest and the lowest ATMs(per 100,000 adults) in Slovenia?
Make the answer very short. 5.09. 